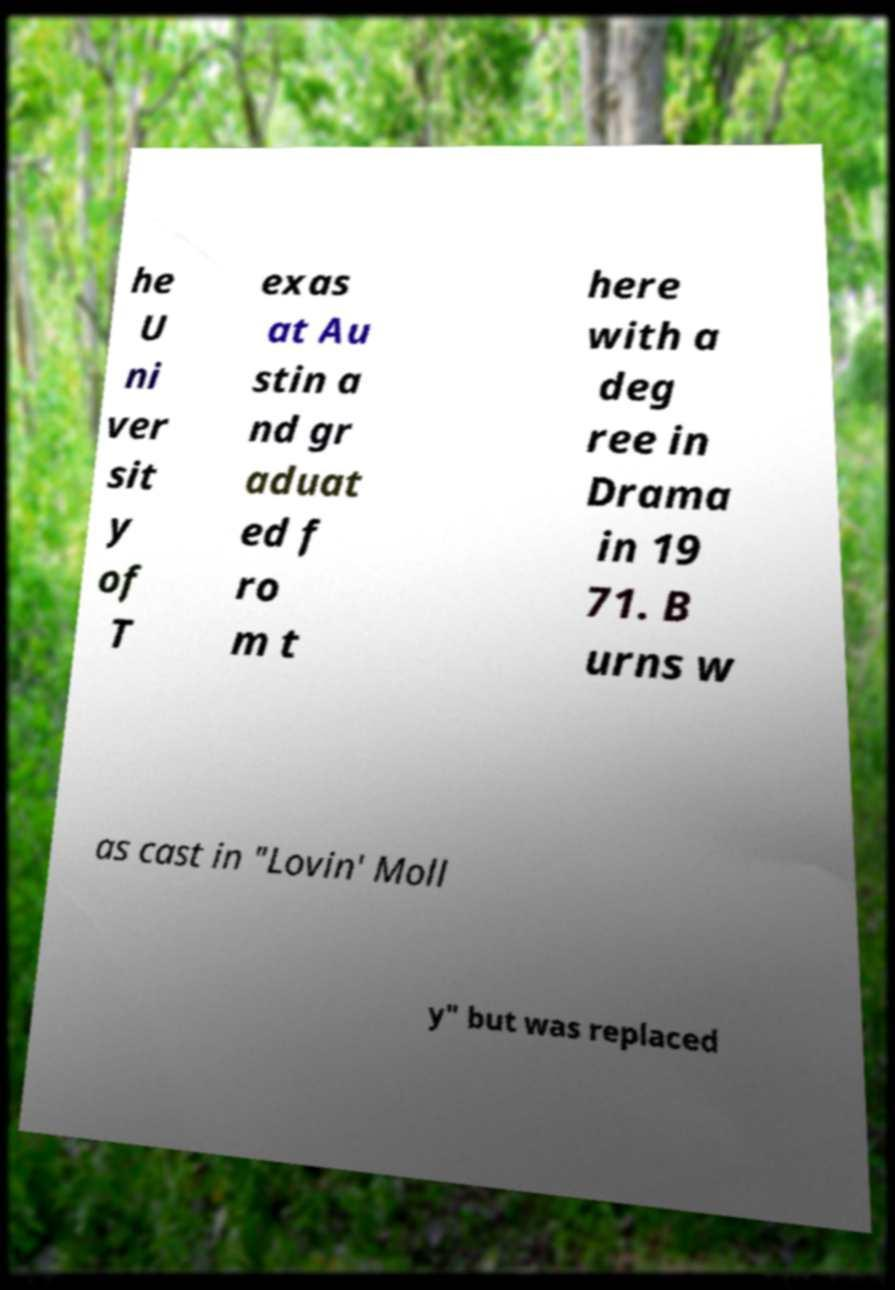Please read and relay the text visible in this image. What does it say? he U ni ver sit y of T exas at Au stin a nd gr aduat ed f ro m t here with a deg ree in Drama in 19 71. B urns w as cast in "Lovin' Moll y" but was replaced 